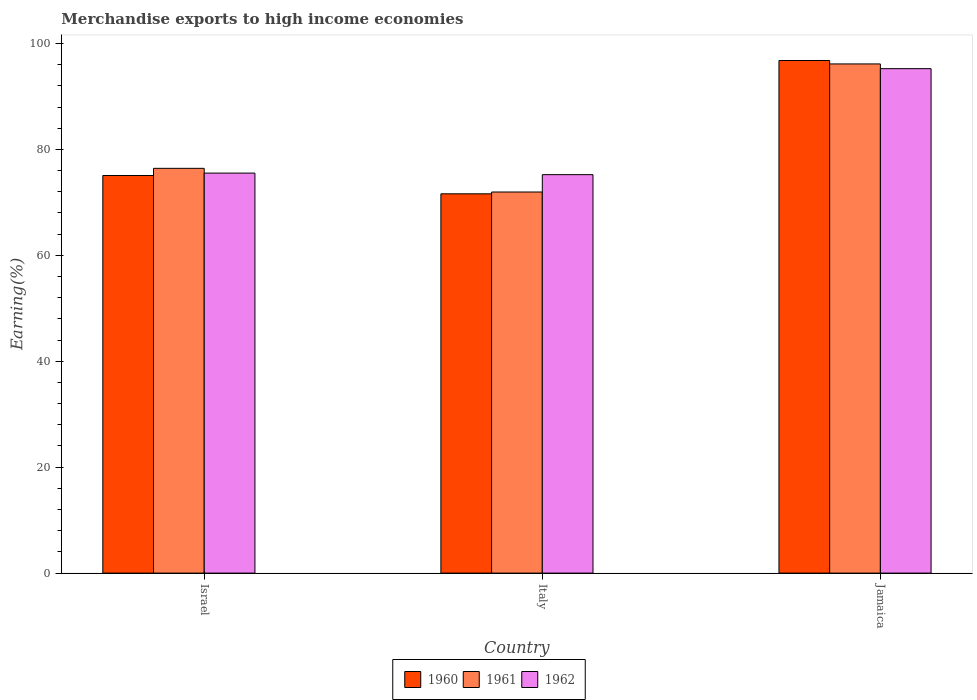Are the number of bars per tick equal to the number of legend labels?
Ensure brevity in your answer.  Yes. Are the number of bars on each tick of the X-axis equal?
Provide a succinct answer. Yes. In how many cases, is the number of bars for a given country not equal to the number of legend labels?
Make the answer very short. 0. What is the percentage of amount earned from merchandise exports in 1960 in Israel?
Your response must be concise. 75.07. Across all countries, what is the maximum percentage of amount earned from merchandise exports in 1962?
Ensure brevity in your answer.  95.24. Across all countries, what is the minimum percentage of amount earned from merchandise exports in 1962?
Provide a succinct answer. 75.23. In which country was the percentage of amount earned from merchandise exports in 1961 maximum?
Give a very brief answer. Jamaica. What is the total percentage of amount earned from merchandise exports in 1961 in the graph?
Ensure brevity in your answer.  244.51. What is the difference between the percentage of amount earned from merchandise exports in 1962 in Italy and that in Jamaica?
Give a very brief answer. -20.01. What is the difference between the percentage of amount earned from merchandise exports in 1962 in Italy and the percentage of amount earned from merchandise exports in 1961 in Jamaica?
Offer a terse response. -20.91. What is the average percentage of amount earned from merchandise exports in 1960 per country?
Your response must be concise. 81.15. What is the difference between the percentage of amount earned from merchandise exports of/in 1962 and percentage of amount earned from merchandise exports of/in 1961 in Italy?
Keep it short and to the point. 3.28. In how many countries, is the percentage of amount earned from merchandise exports in 1960 greater than 88 %?
Make the answer very short. 1. What is the ratio of the percentage of amount earned from merchandise exports in 1960 in Israel to that in Italy?
Offer a terse response. 1.05. Is the difference between the percentage of amount earned from merchandise exports in 1962 in Israel and Italy greater than the difference between the percentage of amount earned from merchandise exports in 1961 in Israel and Italy?
Offer a terse response. No. What is the difference between the highest and the second highest percentage of amount earned from merchandise exports in 1962?
Keep it short and to the point. -0.29. What is the difference between the highest and the lowest percentage of amount earned from merchandise exports in 1960?
Your answer should be compact. 25.17. In how many countries, is the percentage of amount earned from merchandise exports in 1962 greater than the average percentage of amount earned from merchandise exports in 1962 taken over all countries?
Your answer should be compact. 1. Is it the case that in every country, the sum of the percentage of amount earned from merchandise exports in 1962 and percentage of amount earned from merchandise exports in 1960 is greater than the percentage of amount earned from merchandise exports in 1961?
Provide a short and direct response. Yes. Are all the bars in the graph horizontal?
Make the answer very short. No. How many countries are there in the graph?
Make the answer very short. 3. Are the values on the major ticks of Y-axis written in scientific E-notation?
Offer a terse response. No. Does the graph contain any zero values?
Offer a very short reply. No. Does the graph contain grids?
Offer a terse response. No. How are the legend labels stacked?
Your answer should be compact. Horizontal. What is the title of the graph?
Your response must be concise. Merchandise exports to high income economies. Does "1986" appear as one of the legend labels in the graph?
Make the answer very short. No. What is the label or title of the X-axis?
Keep it short and to the point. Country. What is the label or title of the Y-axis?
Keep it short and to the point. Earning(%). What is the Earning(%) in 1960 in Israel?
Make the answer very short. 75.07. What is the Earning(%) in 1961 in Israel?
Keep it short and to the point. 76.42. What is the Earning(%) of 1962 in Israel?
Offer a very short reply. 75.52. What is the Earning(%) in 1960 in Italy?
Provide a short and direct response. 71.61. What is the Earning(%) in 1961 in Italy?
Your response must be concise. 71.95. What is the Earning(%) in 1962 in Italy?
Your answer should be compact. 75.23. What is the Earning(%) of 1960 in Jamaica?
Provide a short and direct response. 96.78. What is the Earning(%) in 1961 in Jamaica?
Ensure brevity in your answer.  96.13. What is the Earning(%) in 1962 in Jamaica?
Give a very brief answer. 95.24. Across all countries, what is the maximum Earning(%) in 1960?
Provide a succinct answer. 96.78. Across all countries, what is the maximum Earning(%) in 1961?
Offer a very short reply. 96.13. Across all countries, what is the maximum Earning(%) in 1962?
Your answer should be compact. 95.24. Across all countries, what is the minimum Earning(%) of 1960?
Your answer should be very brief. 71.61. Across all countries, what is the minimum Earning(%) in 1961?
Your response must be concise. 71.95. Across all countries, what is the minimum Earning(%) in 1962?
Provide a succinct answer. 75.23. What is the total Earning(%) of 1960 in the graph?
Your answer should be very brief. 243.46. What is the total Earning(%) of 1961 in the graph?
Provide a succinct answer. 244.51. What is the total Earning(%) of 1962 in the graph?
Ensure brevity in your answer.  245.99. What is the difference between the Earning(%) in 1960 in Israel and that in Italy?
Your response must be concise. 3.46. What is the difference between the Earning(%) of 1961 in Israel and that in Italy?
Provide a short and direct response. 4.47. What is the difference between the Earning(%) of 1962 in Israel and that in Italy?
Ensure brevity in your answer.  0.29. What is the difference between the Earning(%) in 1960 in Israel and that in Jamaica?
Make the answer very short. -21.71. What is the difference between the Earning(%) in 1961 in Israel and that in Jamaica?
Ensure brevity in your answer.  -19.71. What is the difference between the Earning(%) in 1962 in Israel and that in Jamaica?
Your answer should be very brief. -19.72. What is the difference between the Earning(%) of 1960 in Italy and that in Jamaica?
Keep it short and to the point. -25.17. What is the difference between the Earning(%) of 1961 in Italy and that in Jamaica?
Your answer should be compact. -24.18. What is the difference between the Earning(%) in 1962 in Italy and that in Jamaica?
Your response must be concise. -20.01. What is the difference between the Earning(%) in 1960 in Israel and the Earning(%) in 1961 in Italy?
Give a very brief answer. 3.12. What is the difference between the Earning(%) of 1960 in Israel and the Earning(%) of 1962 in Italy?
Offer a very short reply. -0.16. What is the difference between the Earning(%) of 1961 in Israel and the Earning(%) of 1962 in Italy?
Provide a succinct answer. 1.19. What is the difference between the Earning(%) in 1960 in Israel and the Earning(%) in 1961 in Jamaica?
Give a very brief answer. -21.06. What is the difference between the Earning(%) of 1960 in Israel and the Earning(%) of 1962 in Jamaica?
Make the answer very short. -20.17. What is the difference between the Earning(%) of 1961 in Israel and the Earning(%) of 1962 in Jamaica?
Your answer should be very brief. -18.82. What is the difference between the Earning(%) of 1960 in Italy and the Earning(%) of 1961 in Jamaica?
Your response must be concise. -24.52. What is the difference between the Earning(%) of 1960 in Italy and the Earning(%) of 1962 in Jamaica?
Ensure brevity in your answer.  -23.63. What is the difference between the Earning(%) of 1961 in Italy and the Earning(%) of 1962 in Jamaica?
Your response must be concise. -23.29. What is the average Earning(%) in 1960 per country?
Provide a short and direct response. 81.15. What is the average Earning(%) of 1961 per country?
Your response must be concise. 81.5. What is the average Earning(%) of 1962 per country?
Your answer should be very brief. 82. What is the difference between the Earning(%) in 1960 and Earning(%) in 1961 in Israel?
Ensure brevity in your answer.  -1.35. What is the difference between the Earning(%) in 1960 and Earning(%) in 1962 in Israel?
Keep it short and to the point. -0.45. What is the difference between the Earning(%) in 1961 and Earning(%) in 1962 in Israel?
Make the answer very short. 0.9. What is the difference between the Earning(%) of 1960 and Earning(%) of 1961 in Italy?
Provide a succinct answer. -0.34. What is the difference between the Earning(%) in 1960 and Earning(%) in 1962 in Italy?
Offer a very short reply. -3.62. What is the difference between the Earning(%) of 1961 and Earning(%) of 1962 in Italy?
Your answer should be very brief. -3.28. What is the difference between the Earning(%) in 1960 and Earning(%) in 1961 in Jamaica?
Provide a short and direct response. 0.65. What is the difference between the Earning(%) of 1960 and Earning(%) of 1962 in Jamaica?
Offer a terse response. 1.54. What is the difference between the Earning(%) of 1961 and Earning(%) of 1962 in Jamaica?
Give a very brief answer. 0.89. What is the ratio of the Earning(%) of 1960 in Israel to that in Italy?
Offer a terse response. 1.05. What is the ratio of the Earning(%) in 1961 in Israel to that in Italy?
Your answer should be very brief. 1.06. What is the ratio of the Earning(%) in 1960 in Israel to that in Jamaica?
Your answer should be compact. 0.78. What is the ratio of the Earning(%) in 1961 in Israel to that in Jamaica?
Your answer should be very brief. 0.79. What is the ratio of the Earning(%) in 1962 in Israel to that in Jamaica?
Your answer should be very brief. 0.79. What is the ratio of the Earning(%) of 1960 in Italy to that in Jamaica?
Your answer should be compact. 0.74. What is the ratio of the Earning(%) in 1961 in Italy to that in Jamaica?
Provide a short and direct response. 0.75. What is the ratio of the Earning(%) of 1962 in Italy to that in Jamaica?
Offer a terse response. 0.79. What is the difference between the highest and the second highest Earning(%) in 1960?
Make the answer very short. 21.71. What is the difference between the highest and the second highest Earning(%) in 1961?
Provide a short and direct response. 19.71. What is the difference between the highest and the second highest Earning(%) in 1962?
Provide a succinct answer. 19.72. What is the difference between the highest and the lowest Earning(%) in 1960?
Provide a succinct answer. 25.17. What is the difference between the highest and the lowest Earning(%) of 1961?
Give a very brief answer. 24.18. What is the difference between the highest and the lowest Earning(%) of 1962?
Offer a very short reply. 20.01. 